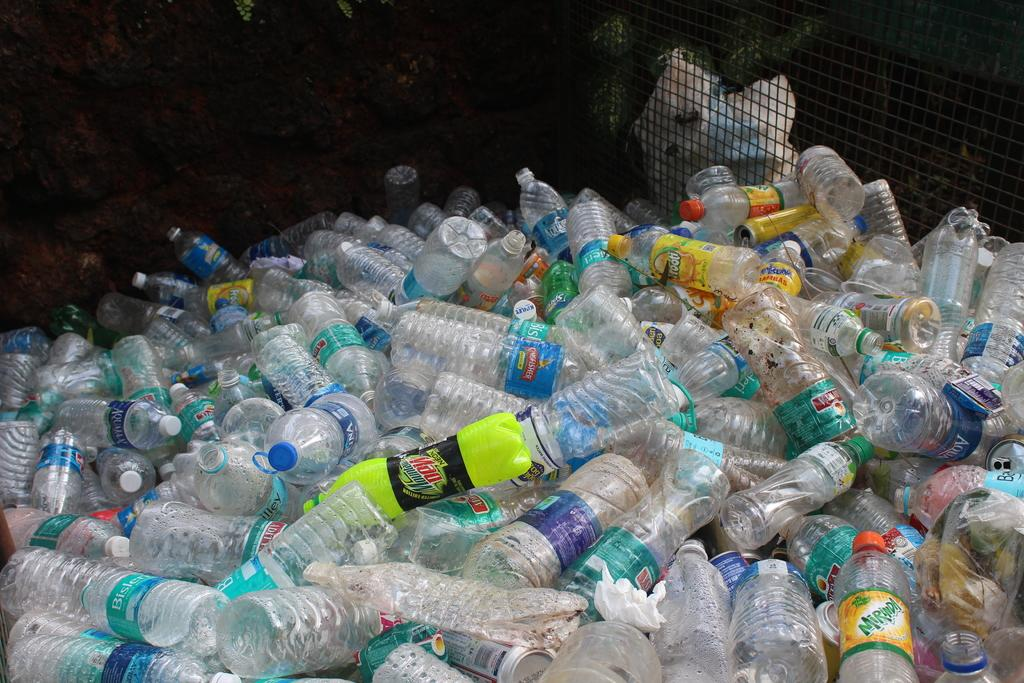<image>
Render a clear and concise summary of the photo. A yellow plastic Mountain Dew bottle in the middle of a large number of clear water bottles. 